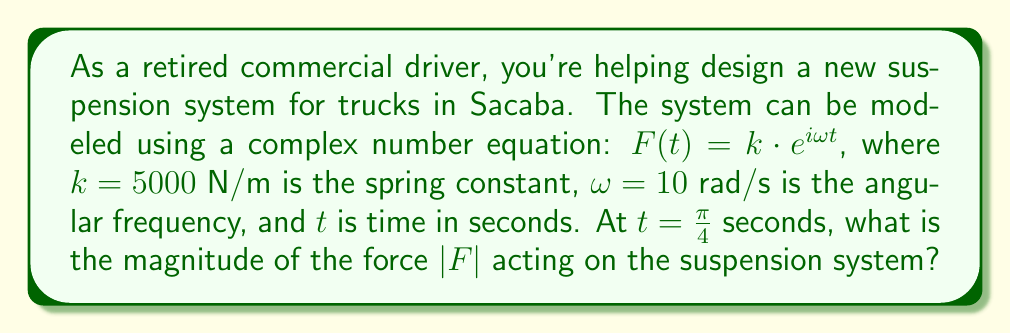Could you help me with this problem? Let's break this down step-by-step:

1) The given equation is $F(t) = k\cdot e^{i\omega t}$

2) We're given:
   $k = 5000$ N/m
   $\omega = 10$ rad/s
   $t = \frac{\pi}{4}$ seconds

3) Substituting these values into the equation:

   $F(\frac{\pi}{4}) = 5000 \cdot e^{i\cdot 10 \cdot \frac{\pi}{4}}$

4) To find the magnitude $|F|$, we use the property that for any complex number $z = re^{i\theta}$, its magnitude is $|z| = r$

5) In our case, $r = 5000$ and the exponential part doesn't affect the magnitude

Therefore, $|F| = 5000$ N/m
Answer: 5000 N/m 